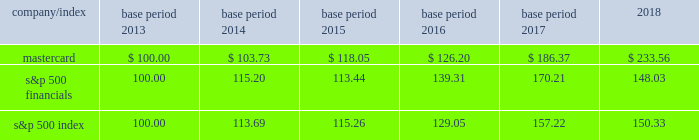Part ii item 5 .
Market for registrant 2019s common equity , related stockholder matters and issuer purchases of equity securities our class a common stock trades on the new york stock exchange under the symbol 201cma 201d .
At february 8 , 2019 , we had 73 stockholders of record for our class a common stock .
We believe that the number of beneficial owners is substantially greater than the number of record holders because a large portion of our class a common stock is held in 201cstreet name 201d by brokers .
There is currently no established public trading market for our class b common stock .
There were approximately 287 holders of record of our non-voting class b common stock as of february 8 , 2019 , constituting approximately 1.1% ( 1.1 % ) of our total outstanding equity .
Stock performance graph the graph and table below compare the cumulative total stockholder return of mastercard 2019s class a common stock , the s&p 500 financials and the s&p 500 index for the five-year period ended december 31 , 2018 .
The graph assumes a $ 100 investment in our class a common stock and both of the indices and the reinvestment of dividends .
Mastercard 2019s class b common stock is not publicly traded or listed on any exchange or dealer quotation system .
Total returns to stockholders for each of the years presented were as follows : indexed returns base period for the years ended december 31 .

What was the percent of the growth of the mastercard from 2013 to 2014? 
Computations: ((103.73 - 100) / 100)
Answer: 0.0373. 